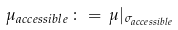<formula> <loc_0><loc_0><loc_500><loc_500>\mu _ { a c c e s s i b l e } \, \colon = \, \mu | _ { \sigma _ { a c c e s s i b l e } }</formula> 